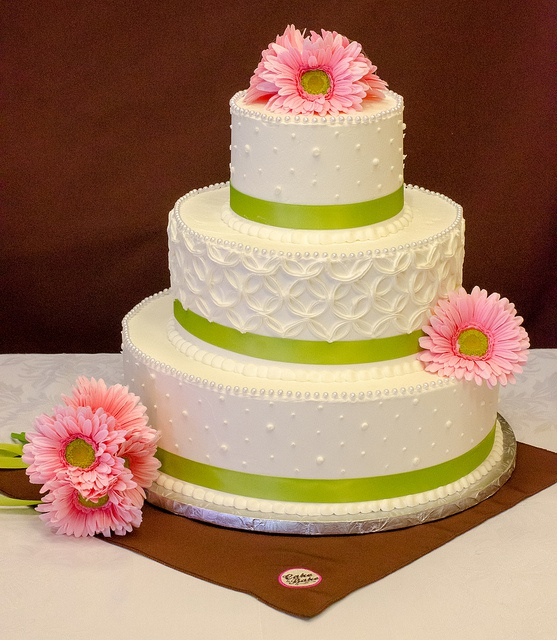Describe the objects in this image and their specific colors. I can see dining table in maroon, tan, and olive tones and cake in maroon, tan, olive, and beige tones in this image. 